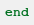<code> <loc_0><loc_0><loc_500><loc_500><_Ruby_>end
</code> 